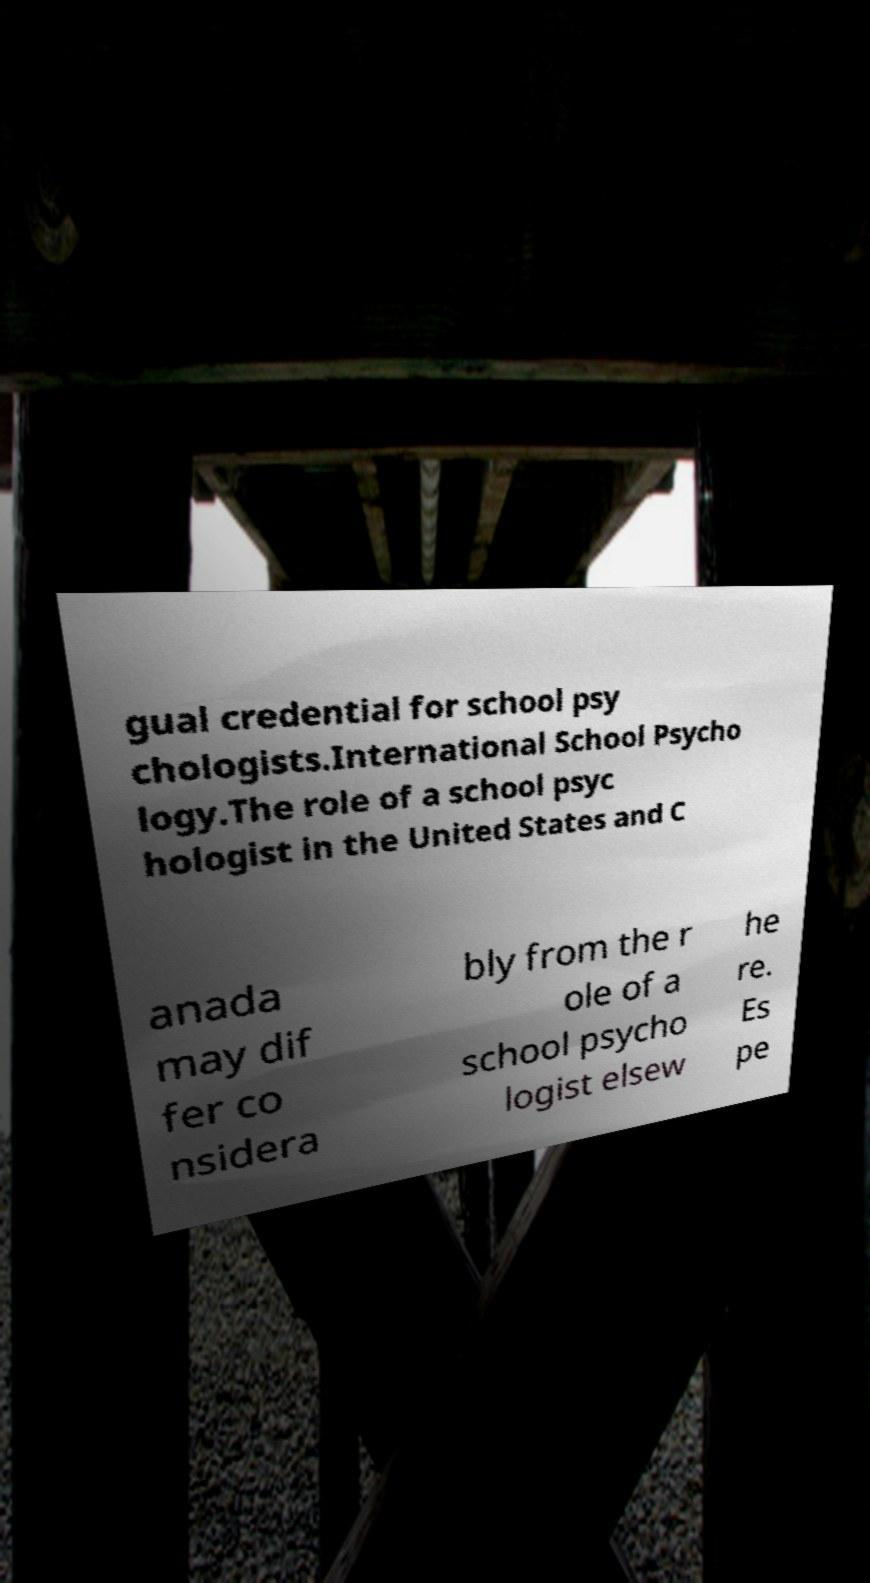Please read and relay the text visible in this image. What does it say? gual credential for school psy chologists.International School Psycho logy.The role of a school psyc hologist in the United States and C anada may dif fer co nsidera bly from the r ole of a school psycho logist elsew he re. Es pe 